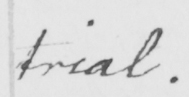Please provide the text content of this handwritten line. trial . 